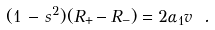<formula> <loc_0><loc_0><loc_500><loc_500>( 1 \, - \, s ^ { 2 } ) ( R _ { + } - R _ { - } ) = 2 \alpha _ { 1 } v \ .</formula> 